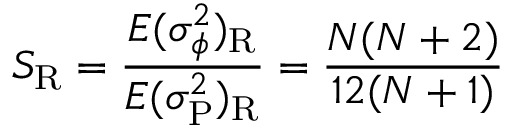Convert formula to latex. <formula><loc_0><loc_0><loc_500><loc_500>S _ { \mathrm R } = { \frac { E ( \sigma _ { \phi } ^ { 2 } ) _ { \mathrm R } } { E ( \sigma _ { \mathrm P } ^ { 2 } ) _ { \mathrm R } } } = { \frac { N ( N + 2 ) } { 1 2 ( N + 1 ) } }</formula> 